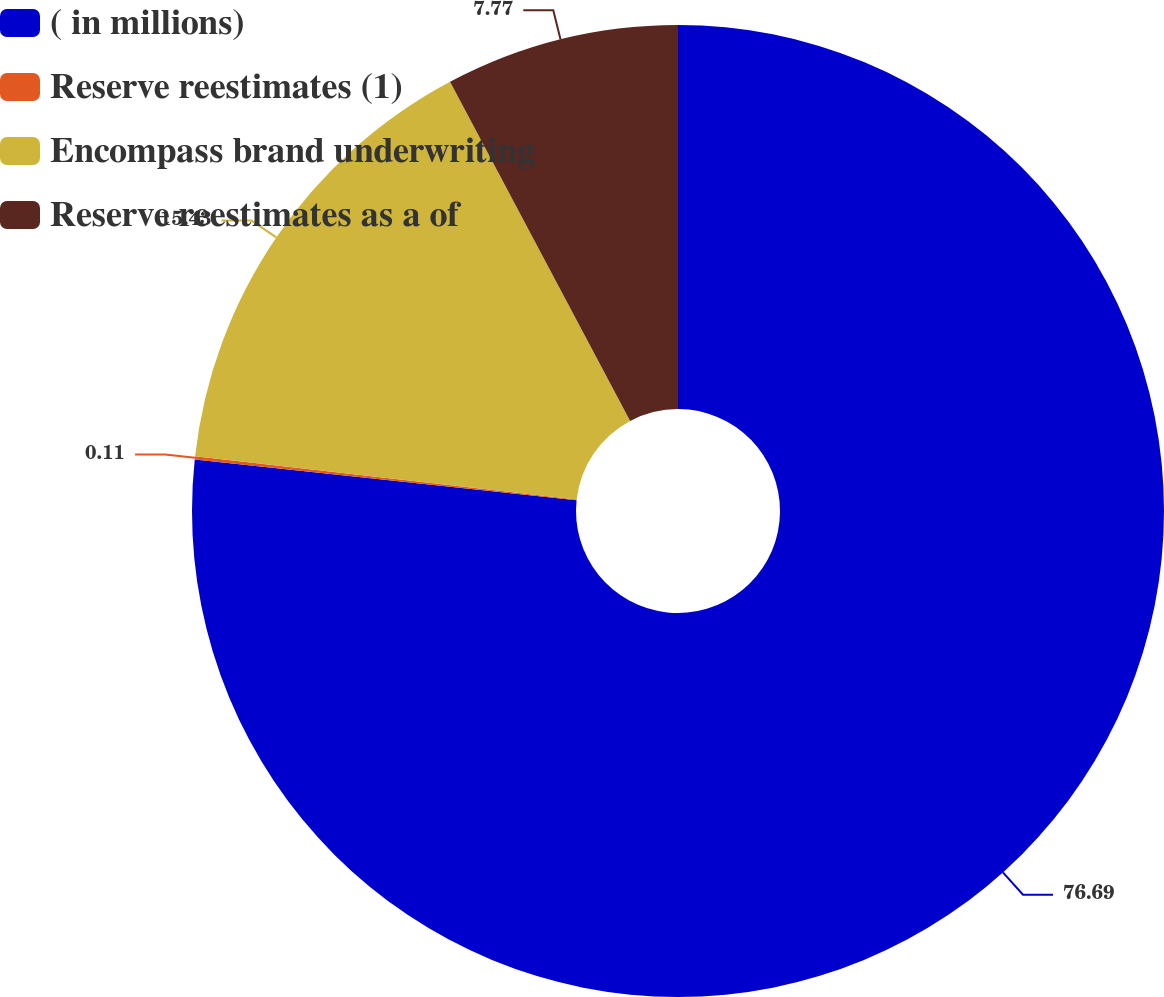Convert chart. <chart><loc_0><loc_0><loc_500><loc_500><pie_chart><fcel>( in millions)<fcel>Reserve reestimates (1)<fcel>Encompass brand underwriting<fcel>Reserve reestimates as a of<nl><fcel>76.69%<fcel>0.11%<fcel>15.43%<fcel>7.77%<nl></chart> 